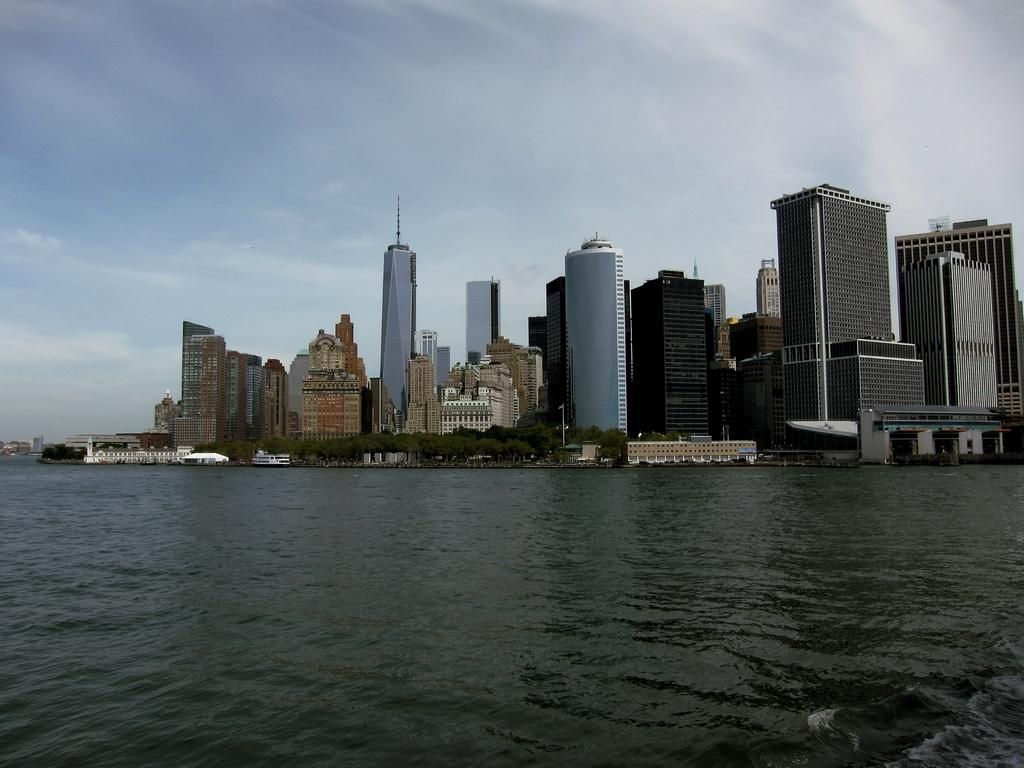What is the primary element visible in the image? There is water in the image. What type of natural vegetation can be seen in the image? There are trees in the image. What type of man-made structures are present in the image? There are buildings in the image. What can be seen in the sky in the image? There are clouds in the image. What else is visible in the sky in the image? The sky is visible in the image. Where is the shelf located in the image? There is no shelf present in the image. What type of grass can be seen growing near the water in the image? There is no grass visible in the image; only water, trees, buildings, clouds, and the sky are present. 